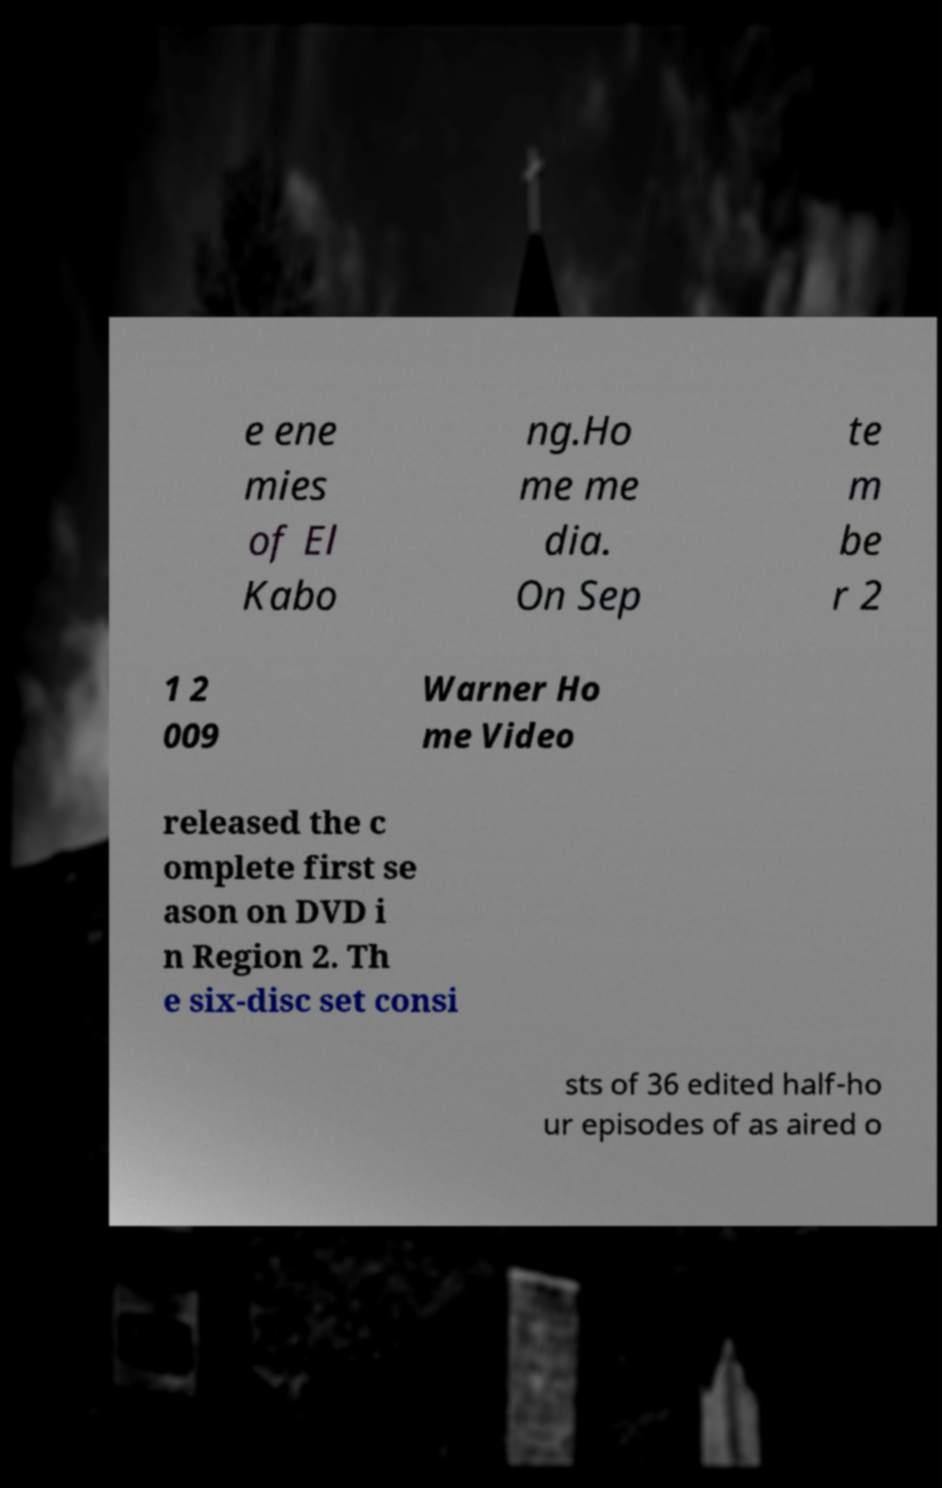I need the written content from this picture converted into text. Can you do that? e ene mies of El Kabo ng.Ho me me dia. On Sep te m be r 2 1 2 009 Warner Ho me Video released the c omplete first se ason on DVD i n Region 2. Th e six-disc set consi sts of 36 edited half-ho ur episodes of as aired o 